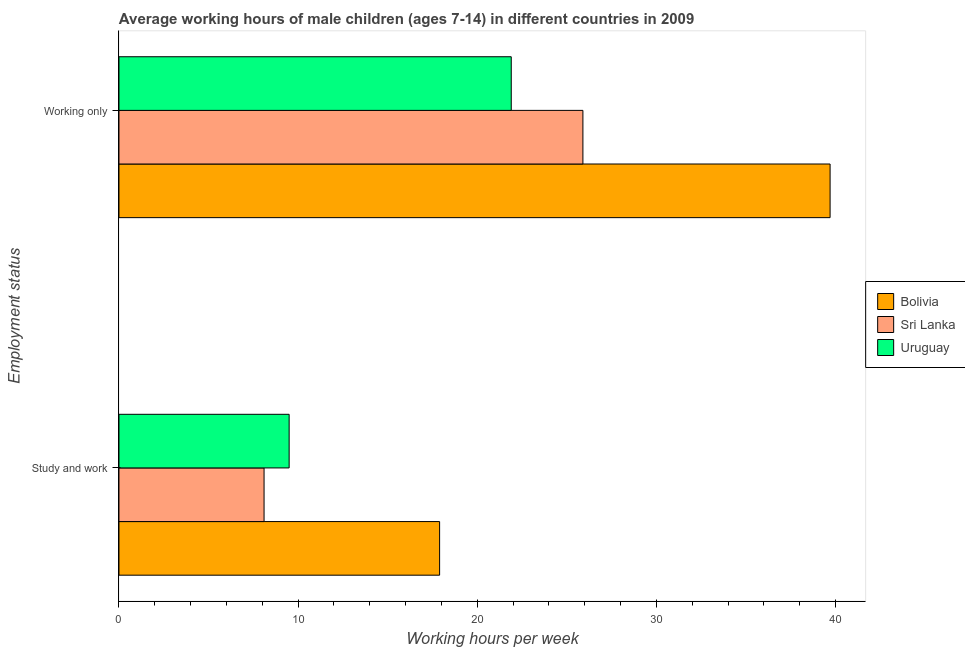How many groups of bars are there?
Your response must be concise. 2. How many bars are there on the 2nd tick from the top?
Your answer should be compact. 3. What is the label of the 2nd group of bars from the top?
Your answer should be compact. Study and work. What is the average working hour of children involved in only work in Uruguay?
Provide a short and direct response. 21.9. Across all countries, what is the maximum average working hour of children involved in study and work?
Your answer should be compact. 17.9. Across all countries, what is the minimum average working hour of children involved in only work?
Your answer should be very brief. 21.9. In which country was the average working hour of children involved in study and work minimum?
Offer a terse response. Sri Lanka. What is the total average working hour of children involved in only work in the graph?
Your response must be concise. 87.5. What is the difference between the average working hour of children involved in only work in Sri Lanka and that in Bolivia?
Offer a very short reply. -13.8. What is the difference between the average working hour of children involved in study and work in Uruguay and the average working hour of children involved in only work in Bolivia?
Ensure brevity in your answer.  -30.2. What is the average average working hour of children involved in only work per country?
Your response must be concise. 29.17. What is the difference between the average working hour of children involved in only work and average working hour of children involved in study and work in Sri Lanka?
Give a very brief answer. 17.8. What is the ratio of the average working hour of children involved in study and work in Bolivia to that in Sri Lanka?
Offer a very short reply. 2.21. Is the average working hour of children involved in only work in Sri Lanka less than that in Bolivia?
Provide a succinct answer. Yes. What does the 1st bar from the top in Working only represents?
Provide a succinct answer. Uruguay. What does the 3rd bar from the bottom in Working only represents?
Ensure brevity in your answer.  Uruguay. How many bars are there?
Your response must be concise. 6. Are all the bars in the graph horizontal?
Your answer should be compact. Yes. How many countries are there in the graph?
Give a very brief answer. 3. Are the values on the major ticks of X-axis written in scientific E-notation?
Your response must be concise. No. Does the graph contain grids?
Make the answer very short. No. Where does the legend appear in the graph?
Provide a succinct answer. Center right. What is the title of the graph?
Your answer should be compact. Average working hours of male children (ages 7-14) in different countries in 2009. What is the label or title of the X-axis?
Keep it short and to the point. Working hours per week. What is the label or title of the Y-axis?
Ensure brevity in your answer.  Employment status. What is the Working hours per week in Bolivia in Study and work?
Your answer should be very brief. 17.9. What is the Working hours per week of Bolivia in Working only?
Keep it short and to the point. 39.7. What is the Working hours per week in Sri Lanka in Working only?
Keep it short and to the point. 25.9. What is the Working hours per week of Uruguay in Working only?
Keep it short and to the point. 21.9. Across all Employment status, what is the maximum Working hours per week of Bolivia?
Your answer should be compact. 39.7. Across all Employment status, what is the maximum Working hours per week in Sri Lanka?
Provide a succinct answer. 25.9. Across all Employment status, what is the maximum Working hours per week of Uruguay?
Give a very brief answer. 21.9. Across all Employment status, what is the minimum Working hours per week of Bolivia?
Give a very brief answer. 17.9. Across all Employment status, what is the minimum Working hours per week of Sri Lanka?
Keep it short and to the point. 8.1. What is the total Working hours per week in Bolivia in the graph?
Your answer should be compact. 57.6. What is the total Working hours per week of Uruguay in the graph?
Offer a terse response. 31.4. What is the difference between the Working hours per week of Bolivia in Study and work and that in Working only?
Provide a short and direct response. -21.8. What is the difference between the Working hours per week in Sri Lanka in Study and work and that in Working only?
Give a very brief answer. -17.8. What is the difference between the Working hours per week of Uruguay in Study and work and that in Working only?
Provide a short and direct response. -12.4. What is the difference between the Working hours per week in Bolivia in Study and work and the Working hours per week in Sri Lanka in Working only?
Ensure brevity in your answer.  -8. What is the average Working hours per week of Bolivia per Employment status?
Offer a terse response. 28.8. What is the average Working hours per week of Sri Lanka per Employment status?
Your response must be concise. 17. What is the difference between the Working hours per week in Bolivia and Working hours per week in Uruguay in Study and work?
Provide a short and direct response. 8.4. What is the ratio of the Working hours per week in Bolivia in Study and work to that in Working only?
Offer a terse response. 0.45. What is the ratio of the Working hours per week in Sri Lanka in Study and work to that in Working only?
Offer a very short reply. 0.31. What is the ratio of the Working hours per week in Uruguay in Study and work to that in Working only?
Your response must be concise. 0.43. What is the difference between the highest and the second highest Working hours per week in Bolivia?
Your response must be concise. 21.8. What is the difference between the highest and the second highest Working hours per week of Sri Lanka?
Your answer should be compact. 17.8. What is the difference between the highest and the lowest Working hours per week in Bolivia?
Make the answer very short. 21.8. 